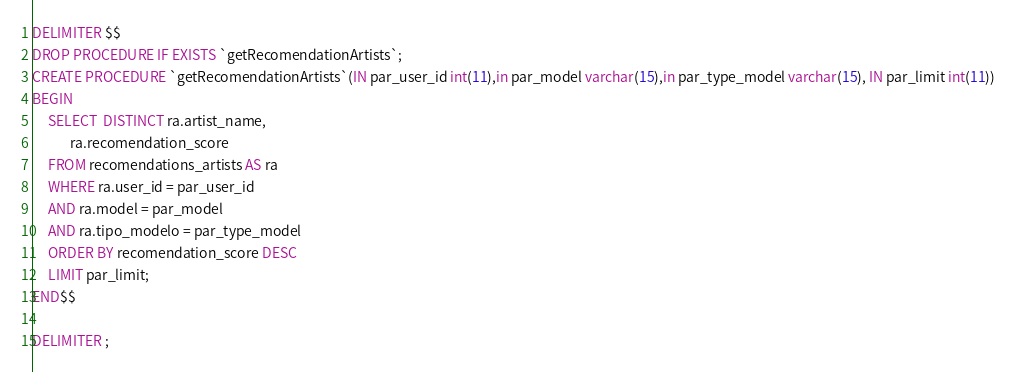Convert code to text. <code><loc_0><loc_0><loc_500><loc_500><_SQL_>DELIMITER $$
DROP PROCEDURE IF EXISTS `getRecomendationArtists`;
CREATE PROCEDURE `getRecomendationArtists`(IN par_user_id int(11),in par_model varchar(15),in par_type_model varchar(15), IN par_limit int(11))
BEGIN
     SELECT  DISTINCT ra.artist_name,
            ra.recomendation_score 
     FROM recomendations_artists AS ra
     WHERE ra.user_id = par_user_id
     AND ra.model = par_model
     AND ra.tipo_modelo = par_type_model
     ORDER BY recomendation_score DESC
     LIMIT par_limit;
END$$

DELIMITER ;</code> 